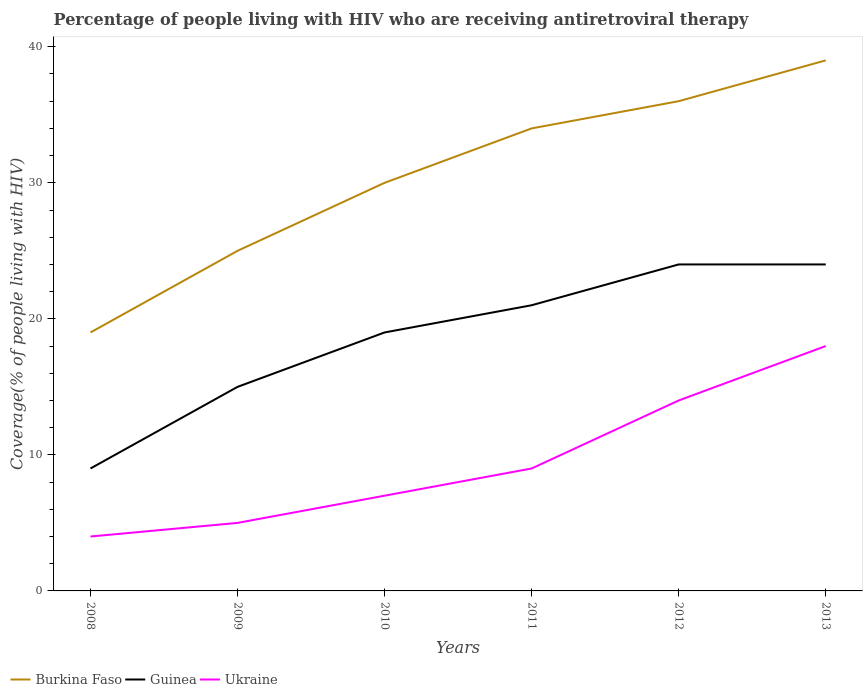Does the line corresponding to Guinea intersect with the line corresponding to Ukraine?
Offer a very short reply. No. Is the number of lines equal to the number of legend labels?
Ensure brevity in your answer.  Yes. Across all years, what is the maximum percentage of the HIV infected people who are receiving antiretroviral therapy in Ukraine?
Your answer should be compact. 4. In which year was the percentage of the HIV infected people who are receiving antiretroviral therapy in Ukraine maximum?
Provide a short and direct response. 2008. What is the total percentage of the HIV infected people who are receiving antiretroviral therapy in Guinea in the graph?
Ensure brevity in your answer.  -15. What is the difference between the highest and the second highest percentage of the HIV infected people who are receiving antiretroviral therapy in Ukraine?
Offer a terse response. 14. What is the difference between the highest and the lowest percentage of the HIV infected people who are receiving antiretroviral therapy in Guinea?
Your answer should be compact. 4. How many lines are there?
Ensure brevity in your answer.  3. What is the difference between two consecutive major ticks on the Y-axis?
Keep it short and to the point. 10. Are the values on the major ticks of Y-axis written in scientific E-notation?
Your answer should be compact. No. Does the graph contain any zero values?
Keep it short and to the point. No. Does the graph contain grids?
Give a very brief answer. No. Where does the legend appear in the graph?
Your answer should be compact. Bottom left. What is the title of the graph?
Your response must be concise. Percentage of people living with HIV who are receiving antiretroviral therapy. What is the label or title of the Y-axis?
Provide a short and direct response. Coverage(% of people living with HIV). What is the Coverage(% of people living with HIV) of Guinea in 2008?
Keep it short and to the point. 9. What is the Coverage(% of people living with HIV) in Ukraine in 2008?
Make the answer very short. 4. What is the Coverage(% of people living with HIV) of Burkina Faso in 2009?
Give a very brief answer. 25. What is the Coverage(% of people living with HIV) of Ukraine in 2009?
Give a very brief answer. 5. What is the Coverage(% of people living with HIV) of Burkina Faso in 2010?
Ensure brevity in your answer.  30. What is the Coverage(% of people living with HIV) in Guinea in 2010?
Make the answer very short. 19. What is the Coverage(% of people living with HIV) in Burkina Faso in 2011?
Offer a terse response. 34. What is the Coverage(% of people living with HIV) in Burkina Faso in 2013?
Your answer should be compact. 39. Across all years, what is the minimum Coverage(% of people living with HIV) of Burkina Faso?
Ensure brevity in your answer.  19. Across all years, what is the minimum Coverage(% of people living with HIV) in Guinea?
Your answer should be compact. 9. Across all years, what is the minimum Coverage(% of people living with HIV) in Ukraine?
Provide a short and direct response. 4. What is the total Coverage(% of people living with HIV) in Burkina Faso in the graph?
Provide a succinct answer. 183. What is the total Coverage(% of people living with HIV) in Guinea in the graph?
Make the answer very short. 112. What is the total Coverage(% of people living with HIV) of Ukraine in the graph?
Your answer should be very brief. 57. What is the difference between the Coverage(% of people living with HIV) in Burkina Faso in 2008 and that in 2009?
Keep it short and to the point. -6. What is the difference between the Coverage(% of people living with HIV) of Burkina Faso in 2008 and that in 2010?
Your answer should be very brief. -11. What is the difference between the Coverage(% of people living with HIV) of Burkina Faso in 2008 and that in 2012?
Offer a very short reply. -17. What is the difference between the Coverage(% of people living with HIV) of Ukraine in 2008 and that in 2012?
Keep it short and to the point. -10. What is the difference between the Coverage(% of people living with HIV) in Ukraine in 2008 and that in 2013?
Give a very brief answer. -14. What is the difference between the Coverage(% of people living with HIV) of Guinea in 2009 and that in 2010?
Your response must be concise. -4. What is the difference between the Coverage(% of people living with HIV) in Ukraine in 2009 and that in 2010?
Your response must be concise. -2. What is the difference between the Coverage(% of people living with HIV) of Burkina Faso in 2009 and that in 2011?
Make the answer very short. -9. What is the difference between the Coverage(% of people living with HIV) in Ukraine in 2009 and that in 2011?
Keep it short and to the point. -4. What is the difference between the Coverage(% of people living with HIV) of Guinea in 2009 and that in 2013?
Your answer should be very brief. -9. What is the difference between the Coverage(% of people living with HIV) of Ukraine in 2009 and that in 2013?
Keep it short and to the point. -13. What is the difference between the Coverage(% of people living with HIV) of Burkina Faso in 2010 and that in 2011?
Offer a very short reply. -4. What is the difference between the Coverage(% of people living with HIV) in Guinea in 2010 and that in 2011?
Your answer should be very brief. -2. What is the difference between the Coverage(% of people living with HIV) in Guinea in 2010 and that in 2012?
Keep it short and to the point. -5. What is the difference between the Coverage(% of people living with HIV) in Burkina Faso in 2010 and that in 2013?
Offer a very short reply. -9. What is the difference between the Coverage(% of people living with HIV) of Ukraine in 2010 and that in 2013?
Your response must be concise. -11. What is the difference between the Coverage(% of people living with HIV) in Guinea in 2011 and that in 2012?
Offer a very short reply. -3. What is the difference between the Coverage(% of people living with HIV) of Guinea in 2011 and that in 2013?
Provide a succinct answer. -3. What is the difference between the Coverage(% of people living with HIV) of Burkina Faso in 2012 and that in 2013?
Ensure brevity in your answer.  -3. What is the difference between the Coverage(% of people living with HIV) in Guinea in 2012 and that in 2013?
Offer a terse response. 0. What is the difference between the Coverage(% of people living with HIV) of Ukraine in 2012 and that in 2013?
Your response must be concise. -4. What is the difference between the Coverage(% of people living with HIV) in Burkina Faso in 2008 and the Coverage(% of people living with HIV) in Guinea in 2009?
Make the answer very short. 4. What is the difference between the Coverage(% of people living with HIV) in Burkina Faso in 2008 and the Coverage(% of people living with HIV) in Ukraine in 2009?
Provide a short and direct response. 14. What is the difference between the Coverage(% of people living with HIV) in Burkina Faso in 2008 and the Coverage(% of people living with HIV) in Guinea in 2010?
Ensure brevity in your answer.  0. What is the difference between the Coverage(% of people living with HIV) in Guinea in 2008 and the Coverage(% of people living with HIV) in Ukraine in 2010?
Provide a short and direct response. 2. What is the difference between the Coverage(% of people living with HIV) of Burkina Faso in 2008 and the Coverage(% of people living with HIV) of Guinea in 2012?
Your response must be concise. -5. What is the difference between the Coverage(% of people living with HIV) of Burkina Faso in 2008 and the Coverage(% of people living with HIV) of Ukraine in 2012?
Make the answer very short. 5. What is the difference between the Coverage(% of people living with HIV) in Burkina Faso in 2008 and the Coverage(% of people living with HIV) in Ukraine in 2013?
Keep it short and to the point. 1. What is the difference between the Coverage(% of people living with HIV) in Guinea in 2008 and the Coverage(% of people living with HIV) in Ukraine in 2013?
Your answer should be compact. -9. What is the difference between the Coverage(% of people living with HIV) in Burkina Faso in 2009 and the Coverage(% of people living with HIV) in Guinea in 2010?
Ensure brevity in your answer.  6. What is the difference between the Coverage(% of people living with HIV) of Burkina Faso in 2009 and the Coverage(% of people living with HIV) of Ukraine in 2010?
Provide a short and direct response. 18. What is the difference between the Coverage(% of people living with HIV) of Guinea in 2009 and the Coverage(% of people living with HIV) of Ukraine in 2010?
Keep it short and to the point. 8. What is the difference between the Coverage(% of people living with HIV) in Burkina Faso in 2009 and the Coverage(% of people living with HIV) in Guinea in 2011?
Provide a short and direct response. 4. What is the difference between the Coverage(% of people living with HIV) of Burkina Faso in 2009 and the Coverage(% of people living with HIV) of Ukraine in 2011?
Your answer should be compact. 16. What is the difference between the Coverage(% of people living with HIV) in Guinea in 2009 and the Coverage(% of people living with HIV) in Ukraine in 2011?
Offer a very short reply. 6. What is the difference between the Coverage(% of people living with HIV) in Burkina Faso in 2009 and the Coverage(% of people living with HIV) in Guinea in 2012?
Provide a succinct answer. 1. What is the difference between the Coverage(% of people living with HIV) of Burkina Faso in 2009 and the Coverage(% of people living with HIV) of Ukraine in 2012?
Your response must be concise. 11. What is the difference between the Coverage(% of people living with HIV) in Guinea in 2009 and the Coverage(% of people living with HIV) in Ukraine in 2012?
Provide a succinct answer. 1. What is the difference between the Coverage(% of people living with HIV) in Burkina Faso in 2010 and the Coverage(% of people living with HIV) in Ukraine in 2011?
Give a very brief answer. 21. What is the difference between the Coverage(% of people living with HIV) of Burkina Faso in 2010 and the Coverage(% of people living with HIV) of Guinea in 2012?
Offer a terse response. 6. What is the difference between the Coverage(% of people living with HIV) of Burkina Faso in 2010 and the Coverage(% of people living with HIV) of Ukraine in 2012?
Provide a succinct answer. 16. What is the difference between the Coverage(% of people living with HIV) of Guinea in 2010 and the Coverage(% of people living with HIV) of Ukraine in 2012?
Your answer should be very brief. 5. What is the difference between the Coverage(% of people living with HIV) in Guinea in 2011 and the Coverage(% of people living with HIV) in Ukraine in 2012?
Offer a terse response. 7. What is the difference between the Coverage(% of people living with HIV) in Burkina Faso in 2011 and the Coverage(% of people living with HIV) in Guinea in 2013?
Your answer should be compact. 10. What is the difference between the Coverage(% of people living with HIV) of Burkina Faso in 2011 and the Coverage(% of people living with HIV) of Ukraine in 2013?
Provide a short and direct response. 16. What is the difference between the Coverage(% of people living with HIV) in Guinea in 2011 and the Coverage(% of people living with HIV) in Ukraine in 2013?
Ensure brevity in your answer.  3. What is the difference between the Coverage(% of people living with HIV) in Burkina Faso in 2012 and the Coverage(% of people living with HIV) in Guinea in 2013?
Your response must be concise. 12. What is the average Coverage(% of people living with HIV) in Burkina Faso per year?
Ensure brevity in your answer.  30.5. What is the average Coverage(% of people living with HIV) of Guinea per year?
Provide a short and direct response. 18.67. In the year 2008, what is the difference between the Coverage(% of people living with HIV) in Guinea and Coverage(% of people living with HIV) in Ukraine?
Offer a very short reply. 5. In the year 2009, what is the difference between the Coverage(% of people living with HIV) of Guinea and Coverage(% of people living with HIV) of Ukraine?
Offer a terse response. 10. In the year 2010, what is the difference between the Coverage(% of people living with HIV) of Burkina Faso and Coverage(% of people living with HIV) of Guinea?
Make the answer very short. 11. In the year 2011, what is the difference between the Coverage(% of people living with HIV) in Burkina Faso and Coverage(% of people living with HIV) in Guinea?
Ensure brevity in your answer.  13. In the year 2011, what is the difference between the Coverage(% of people living with HIV) in Guinea and Coverage(% of people living with HIV) in Ukraine?
Offer a very short reply. 12. In the year 2012, what is the difference between the Coverage(% of people living with HIV) of Guinea and Coverage(% of people living with HIV) of Ukraine?
Give a very brief answer. 10. In the year 2013, what is the difference between the Coverage(% of people living with HIV) of Burkina Faso and Coverage(% of people living with HIV) of Guinea?
Provide a short and direct response. 15. In the year 2013, what is the difference between the Coverage(% of people living with HIV) of Burkina Faso and Coverage(% of people living with HIV) of Ukraine?
Your answer should be compact. 21. What is the ratio of the Coverage(% of people living with HIV) of Burkina Faso in 2008 to that in 2009?
Your answer should be compact. 0.76. What is the ratio of the Coverage(% of people living with HIV) of Ukraine in 2008 to that in 2009?
Your answer should be very brief. 0.8. What is the ratio of the Coverage(% of people living with HIV) in Burkina Faso in 2008 to that in 2010?
Offer a very short reply. 0.63. What is the ratio of the Coverage(% of people living with HIV) in Guinea in 2008 to that in 2010?
Provide a short and direct response. 0.47. What is the ratio of the Coverage(% of people living with HIV) of Ukraine in 2008 to that in 2010?
Ensure brevity in your answer.  0.57. What is the ratio of the Coverage(% of people living with HIV) in Burkina Faso in 2008 to that in 2011?
Give a very brief answer. 0.56. What is the ratio of the Coverage(% of people living with HIV) in Guinea in 2008 to that in 2011?
Keep it short and to the point. 0.43. What is the ratio of the Coverage(% of people living with HIV) in Ukraine in 2008 to that in 2011?
Provide a succinct answer. 0.44. What is the ratio of the Coverage(% of people living with HIV) of Burkina Faso in 2008 to that in 2012?
Your response must be concise. 0.53. What is the ratio of the Coverage(% of people living with HIV) in Ukraine in 2008 to that in 2012?
Your response must be concise. 0.29. What is the ratio of the Coverage(% of people living with HIV) in Burkina Faso in 2008 to that in 2013?
Ensure brevity in your answer.  0.49. What is the ratio of the Coverage(% of people living with HIV) in Guinea in 2008 to that in 2013?
Ensure brevity in your answer.  0.38. What is the ratio of the Coverage(% of people living with HIV) in Ukraine in 2008 to that in 2013?
Keep it short and to the point. 0.22. What is the ratio of the Coverage(% of people living with HIV) of Guinea in 2009 to that in 2010?
Keep it short and to the point. 0.79. What is the ratio of the Coverage(% of people living with HIV) of Burkina Faso in 2009 to that in 2011?
Keep it short and to the point. 0.74. What is the ratio of the Coverage(% of people living with HIV) of Guinea in 2009 to that in 2011?
Make the answer very short. 0.71. What is the ratio of the Coverage(% of people living with HIV) in Ukraine in 2009 to that in 2011?
Ensure brevity in your answer.  0.56. What is the ratio of the Coverage(% of people living with HIV) of Burkina Faso in 2009 to that in 2012?
Provide a short and direct response. 0.69. What is the ratio of the Coverage(% of people living with HIV) of Ukraine in 2009 to that in 2012?
Provide a succinct answer. 0.36. What is the ratio of the Coverage(% of people living with HIV) in Burkina Faso in 2009 to that in 2013?
Keep it short and to the point. 0.64. What is the ratio of the Coverage(% of people living with HIV) of Ukraine in 2009 to that in 2013?
Provide a short and direct response. 0.28. What is the ratio of the Coverage(% of people living with HIV) of Burkina Faso in 2010 to that in 2011?
Your answer should be very brief. 0.88. What is the ratio of the Coverage(% of people living with HIV) in Guinea in 2010 to that in 2011?
Make the answer very short. 0.9. What is the ratio of the Coverage(% of people living with HIV) in Guinea in 2010 to that in 2012?
Make the answer very short. 0.79. What is the ratio of the Coverage(% of people living with HIV) in Ukraine in 2010 to that in 2012?
Offer a very short reply. 0.5. What is the ratio of the Coverage(% of people living with HIV) in Burkina Faso in 2010 to that in 2013?
Your answer should be very brief. 0.77. What is the ratio of the Coverage(% of people living with HIV) of Guinea in 2010 to that in 2013?
Provide a succinct answer. 0.79. What is the ratio of the Coverage(% of people living with HIV) of Ukraine in 2010 to that in 2013?
Offer a very short reply. 0.39. What is the ratio of the Coverage(% of people living with HIV) in Ukraine in 2011 to that in 2012?
Your answer should be very brief. 0.64. What is the ratio of the Coverage(% of people living with HIV) in Burkina Faso in 2011 to that in 2013?
Give a very brief answer. 0.87. What is the ratio of the Coverage(% of people living with HIV) in Guinea in 2011 to that in 2013?
Make the answer very short. 0.88. What is the ratio of the Coverage(% of people living with HIV) of Ukraine in 2011 to that in 2013?
Offer a terse response. 0.5. What is the ratio of the Coverage(% of people living with HIV) in Burkina Faso in 2012 to that in 2013?
Make the answer very short. 0.92. What is the ratio of the Coverage(% of people living with HIV) of Guinea in 2012 to that in 2013?
Keep it short and to the point. 1. What is the ratio of the Coverage(% of people living with HIV) in Ukraine in 2012 to that in 2013?
Your response must be concise. 0.78. What is the difference between the highest and the second highest Coverage(% of people living with HIV) of Guinea?
Your response must be concise. 0. What is the difference between the highest and the lowest Coverage(% of people living with HIV) in Guinea?
Provide a short and direct response. 15. What is the difference between the highest and the lowest Coverage(% of people living with HIV) of Ukraine?
Ensure brevity in your answer.  14. 